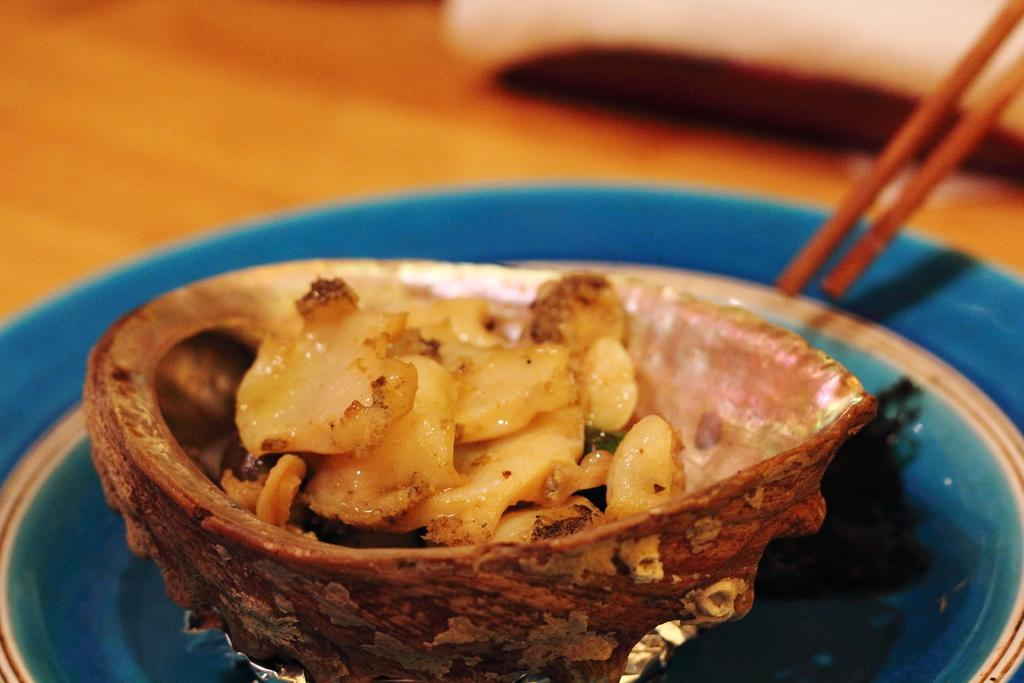What type of furniture is present in the image? There is a table in the image. What is placed on the table? There is a plate and a wooden bowl on the table. What is inside the wooden bowl? There is a food item in the wooden bowl. What type of utensils are visible in the image? There are wooden sticks in the image. How does the crowd react to the story being told in the image? There is no crowd or story present in the image; it only features a table, a plate, a wooden bowl, a food item, and wooden sticks. 